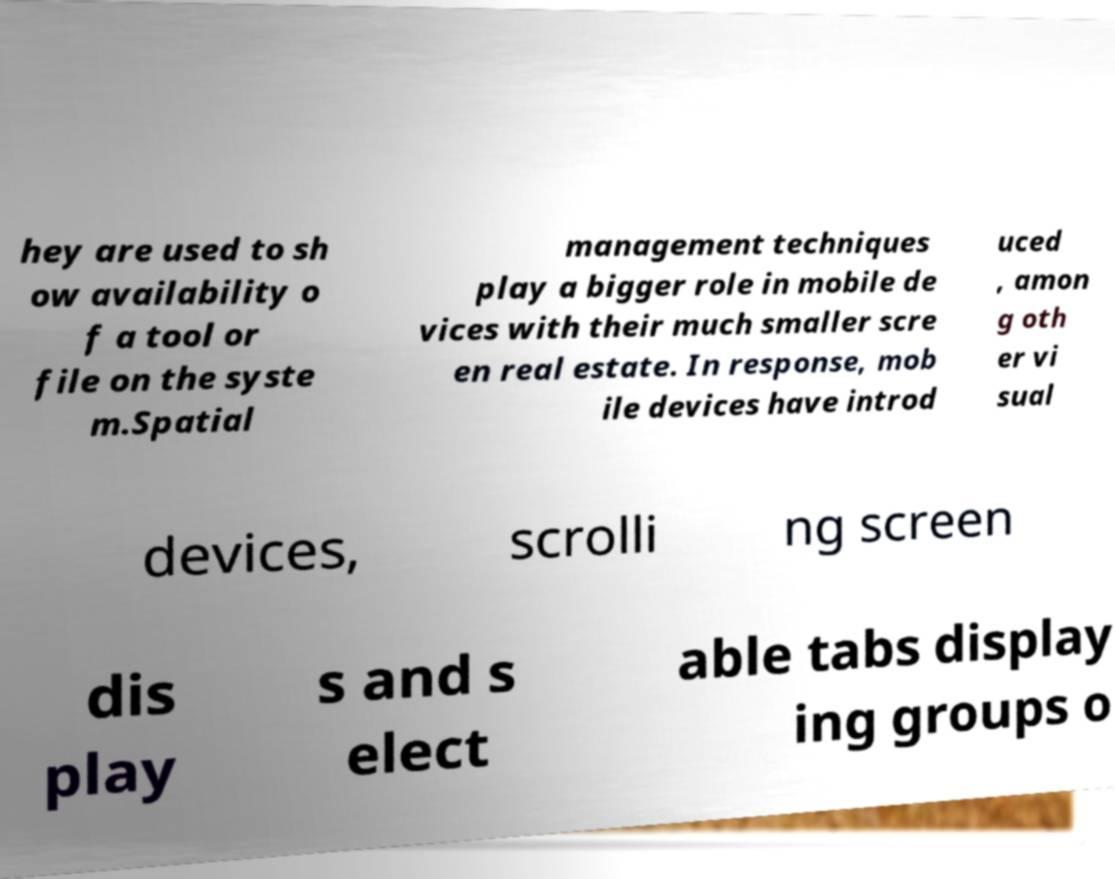There's text embedded in this image that I need extracted. Can you transcribe it verbatim? hey are used to sh ow availability o f a tool or file on the syste m.Spatial management techniques play a bigger role in mobile de vices with their much smaller scre en real estate. In response, mob ile devices have introd uced , amon g oth er vi sual devices, scrolli ng screen dis play s and s elect able tabs display ing groups o 